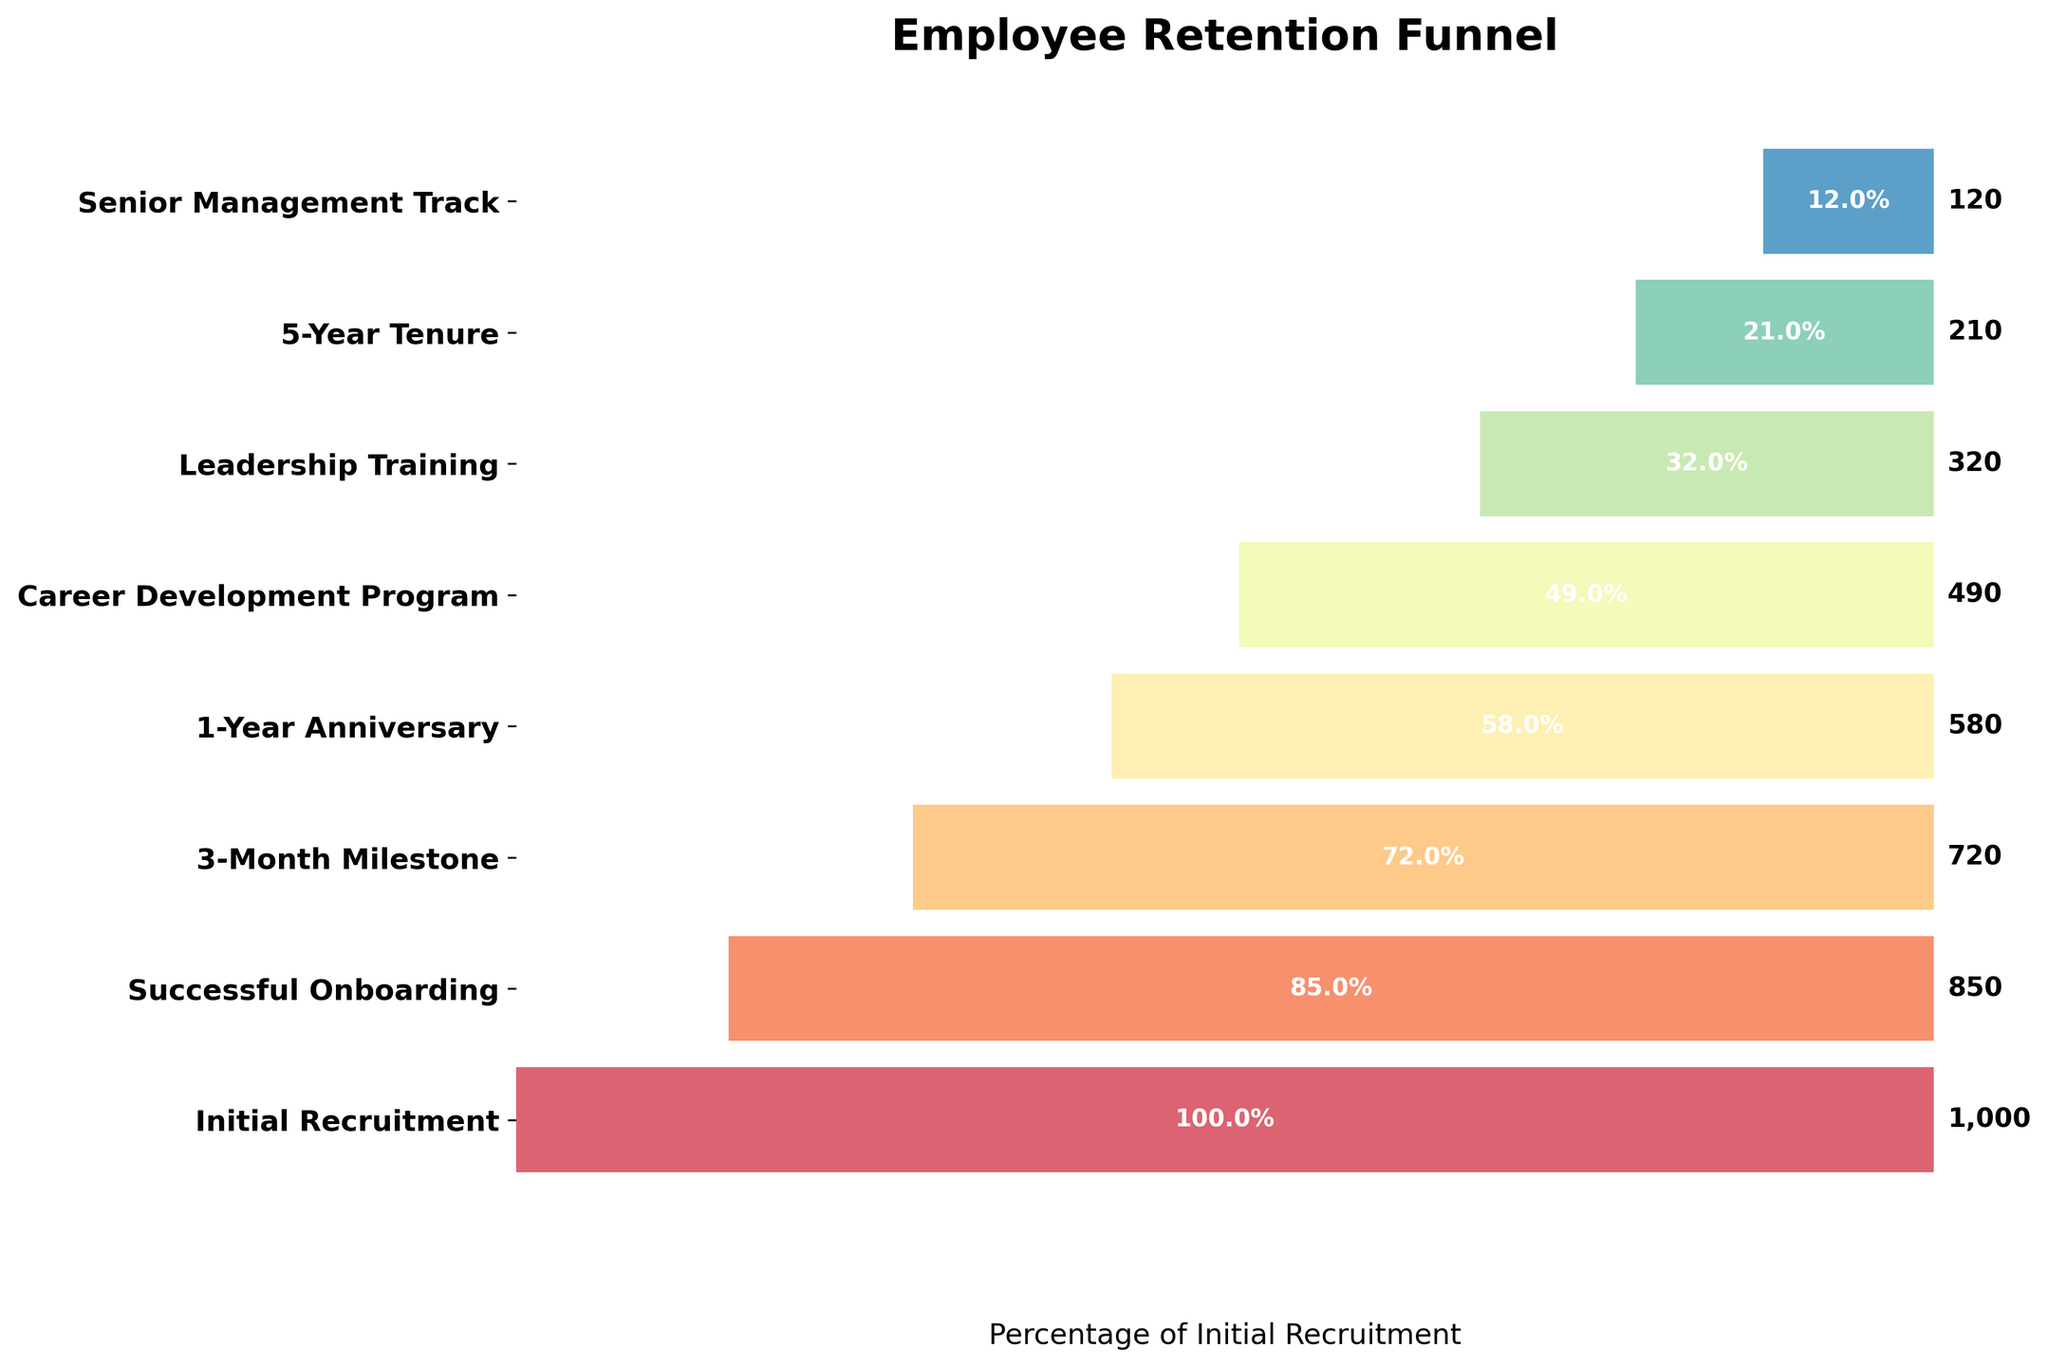How many stages are shown in the employee retention funnel? There are 8 unique stages listed in the funnel. Each stage represents a different milestone in employee retention.
Answer: 8 What is the title of the chart? The title of the chart is located at the top and reads "Employee Retention Funnel."
Answer: Employee Retention Funnel Which stage has the highest number of employees? The stage with the highest number of employees is the "Initial Recruitment" stage, which has 1000 employees. This is depicted by the longest bar in the funnel chart.
Answer: Initial Recruitment How many employees are retained after the 3-Month Milestone? The number of employees retained after the 3-Month Milestone is directly indicated next to that bar. It shows a value of 720 employees.
Answer: 720 What is the difference in the number of employees between the Initial Recruitment and the 1-Year Anniversary stages? The "Initial Recruitment" stage has 1000 employees and the "1-Year Anniversary" stage has 580 employees. The difference is 1000 - 580 = 420 employees.
Answer: 420 Which stage has approximately one-third the number of employees compared to the Initial Recruitment stage? The Initial Recruitment stage has 1000 employees. One-third of that is approximately 333.3. By looking at the chart, the "Leadership Training" stage with 320 employees is the closest to this value.
Answer: Leadership Training What percentage of initially recruited employees remain at the 5-Year Tenure stage? The percentage is given as the width within the plot. For the 5-Year Tenure stage, 210 employees are retained out of the initial 1000. Hence, the percentage is (210/1000) * 100 = 21%.
Answer: 21% How many more employees participate in the Career Development Program than the Senior Management Track? The Career Development Program has 490 employees, while the Senior Management Track has 120. So, the difference is 490 - 120 = 370 employees.
Answer: 370 Is the drop-off rate higher between the Initial Recruitment and Successful Onboarding stages or between the Career Development Program and Leadership Training stages? The drop-off between the Initial Recruitment (1000) and Successful Onboarding (850) is 1000 - 850 = 150 employees. The drop-off between the Career Development Program (490) and Leadership Training (320) is 490 - 320 = 170 employees. Therefore, the drop-off rate is higher between the Career Development Program and Leadership Training stages.
Answer: Career Development Program to Leadership Training Which stage shows the smallest percentage of employee retention? By examining the bar widths within the chart, the "Senior Management Track" stage has the smallest percentage, representing 120 out of the initial 1000 employees, which is 12%.
Answer: Senior Management Track 